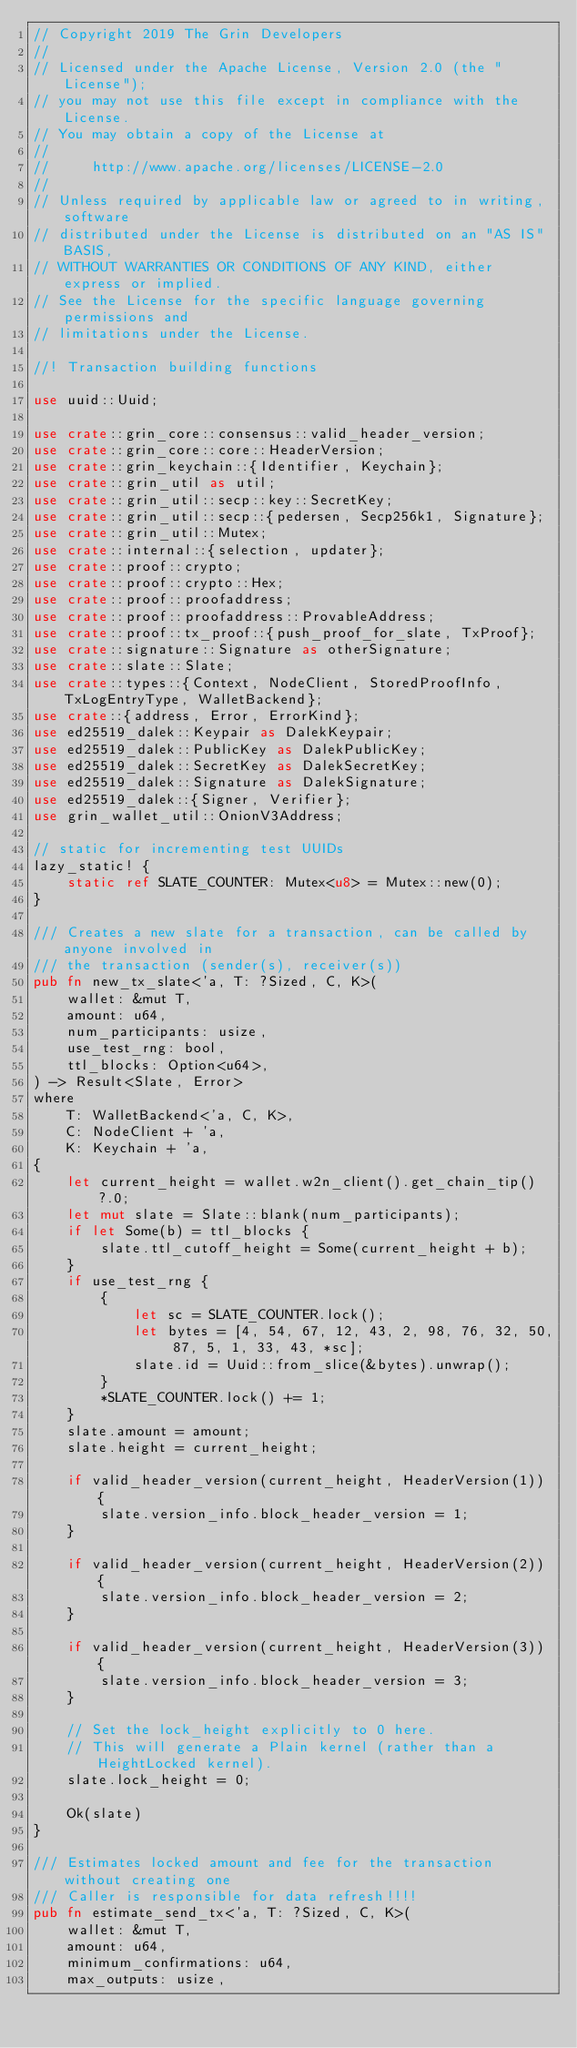<code> <loc_0><loc_0><loc_500><loc_500><_Rust_>// Copyright 2019 The Grin Developers
//
// Licensed under the Apache License, Version 2.0 (the "License");
// you may not use this file except in compliance with the License.
// You may obtain a copy of the License at
//
//     http://www.apache.org/licenses/LICENSE-2.0
//
// Unless required by applicable law or agreed to in writing, software
// distributed under the License is distributed on an "AS IS" BASIS,
// WITHOUT WARRANTIES OR CONDITIONS OF ANY KIND, either express or implied.
// See the License for the specific language governing permissions and
// limitations under the License.

//! Transaction building functions

use uuid::Uuid;

use crate::grin_core::consensus::valid_header_version;
use crate::grin_core::core::HeaderVersion;
use crate::grin_keychain::{Identifier, Keychain};
use crate::grin_util as util;
use crate::grin_util::secp::key::SecretKey;
use crate::grin_util::secp::{pedersen, Secp256k1, Signature};
use crate::grin_util::Mutex;
use crate::internal::{selection, updater};
use crate::proof::crypto;
use crate::proof::crypto::Hex;
use crate::proof::proofaddress;
use crate::proof::proofaddress::ProvableAddress;
use crate::proof::tx_proof::{push_proof_for_slate, TxProof};
use crate::signature::Signature as otherSignature;
use crate::slate::Slate;
use crate::types::{Context, NodeClient, StoredProofInfo, TxLogEntryType, WalletBackend};
use crate::{address, Error, ErrorKind};
use ed25519_dalek::Keypair as DalekKeypair;
use ed25519_dalek::PublicKey as DalekPublicKey;
use ed25519_dalek::SecretKey as DalekSecretKey;
use ed25519_dalek::Signature as DalekSignature;
use ed25519_dalek::{Signer, Verifier};
use grin_wallet_util::OnionV3Address;

// static for incrementing test UUIDs
lazy_static! {
	static ref SLATE_COUNTER: Mutex<u8> = Mutex::new(0);
}

/// Creates a new slate for a transaction, can be called by anyone involved in
/// the transaction (sender(s), receiver(s))
pub fn new_tx_slate<'a, T: ?Sized, C, K>(
	wallet: &mut T,
	amount: u64,
	num_participants: usize,
	use_test_rng: bool,
	ttl_blocks: Option<u64>,
) -> Result<Slate, Error>
where
	T: WalletBackend<'a, C, K>,
	C: NodeClient + 'a,
	K: Keychain + 'a,
{
	let current_height = wallet.w2n_client().get_chain_tip()?.0;
	let mut slate = Slate::blank(num_participants);
	if let Some(b) = ttl_blocks {
		slate.ttl_cutoff_height = Some(current_height + b);
	}
	if use_test_rng {
		{
			let sc = SLATE_COUNTER.lock();
			let bytes = [4, 54, 67, 12, 43, 2, 98, 76, 32, 50, 87, 5, 1, 33, 43, *sc];
			slate.id = Uuid::from_slice(&bytes).unwrap();
		}
		*SLATE_COUNTER.lock() += 1;
	}
	slate.amount = amount;
	slate.height = current_height;

	if valid_header_version(current_height, HeaderVersion(1)) {
		slate.version_info.block_header_version = 1;
	}

	if valid_header_version(current_height, HeaderVersion(2)) {
		slate.version_info.block_header_version = 2;
	}

	if valid_header_version(current_height, HeaderVersion(3)) {
		slate.version_info.block_header_version = 3;
	}

	// Set the lock_height explicitly to 0 here.
	// This will generate a Plain kernel (rather than a HeightLocked kernel).
	slate.lock_height = 0;

	Ok(slate)
}

/// Estimates locked amount and fee for the transaction without creating one
/// Caller is responsible for data refresh!!!!
pub fn estimate_send_tx<'a, T: ?Sized, C, K>(
	wallet: &mut T,
	amount: u64,
	minimum_confirmations: u64,
	max_outputs: usize,</code> 